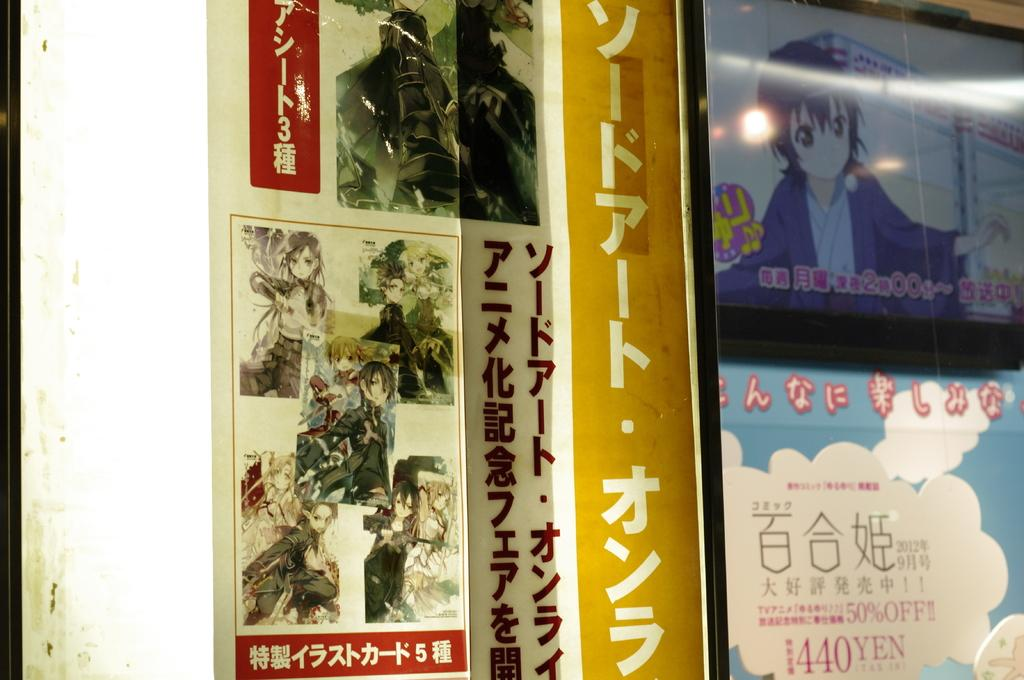<image>
Summarize the visual content of the image. Several posters of Japanese Manga art, one is marked 440 Yen. 